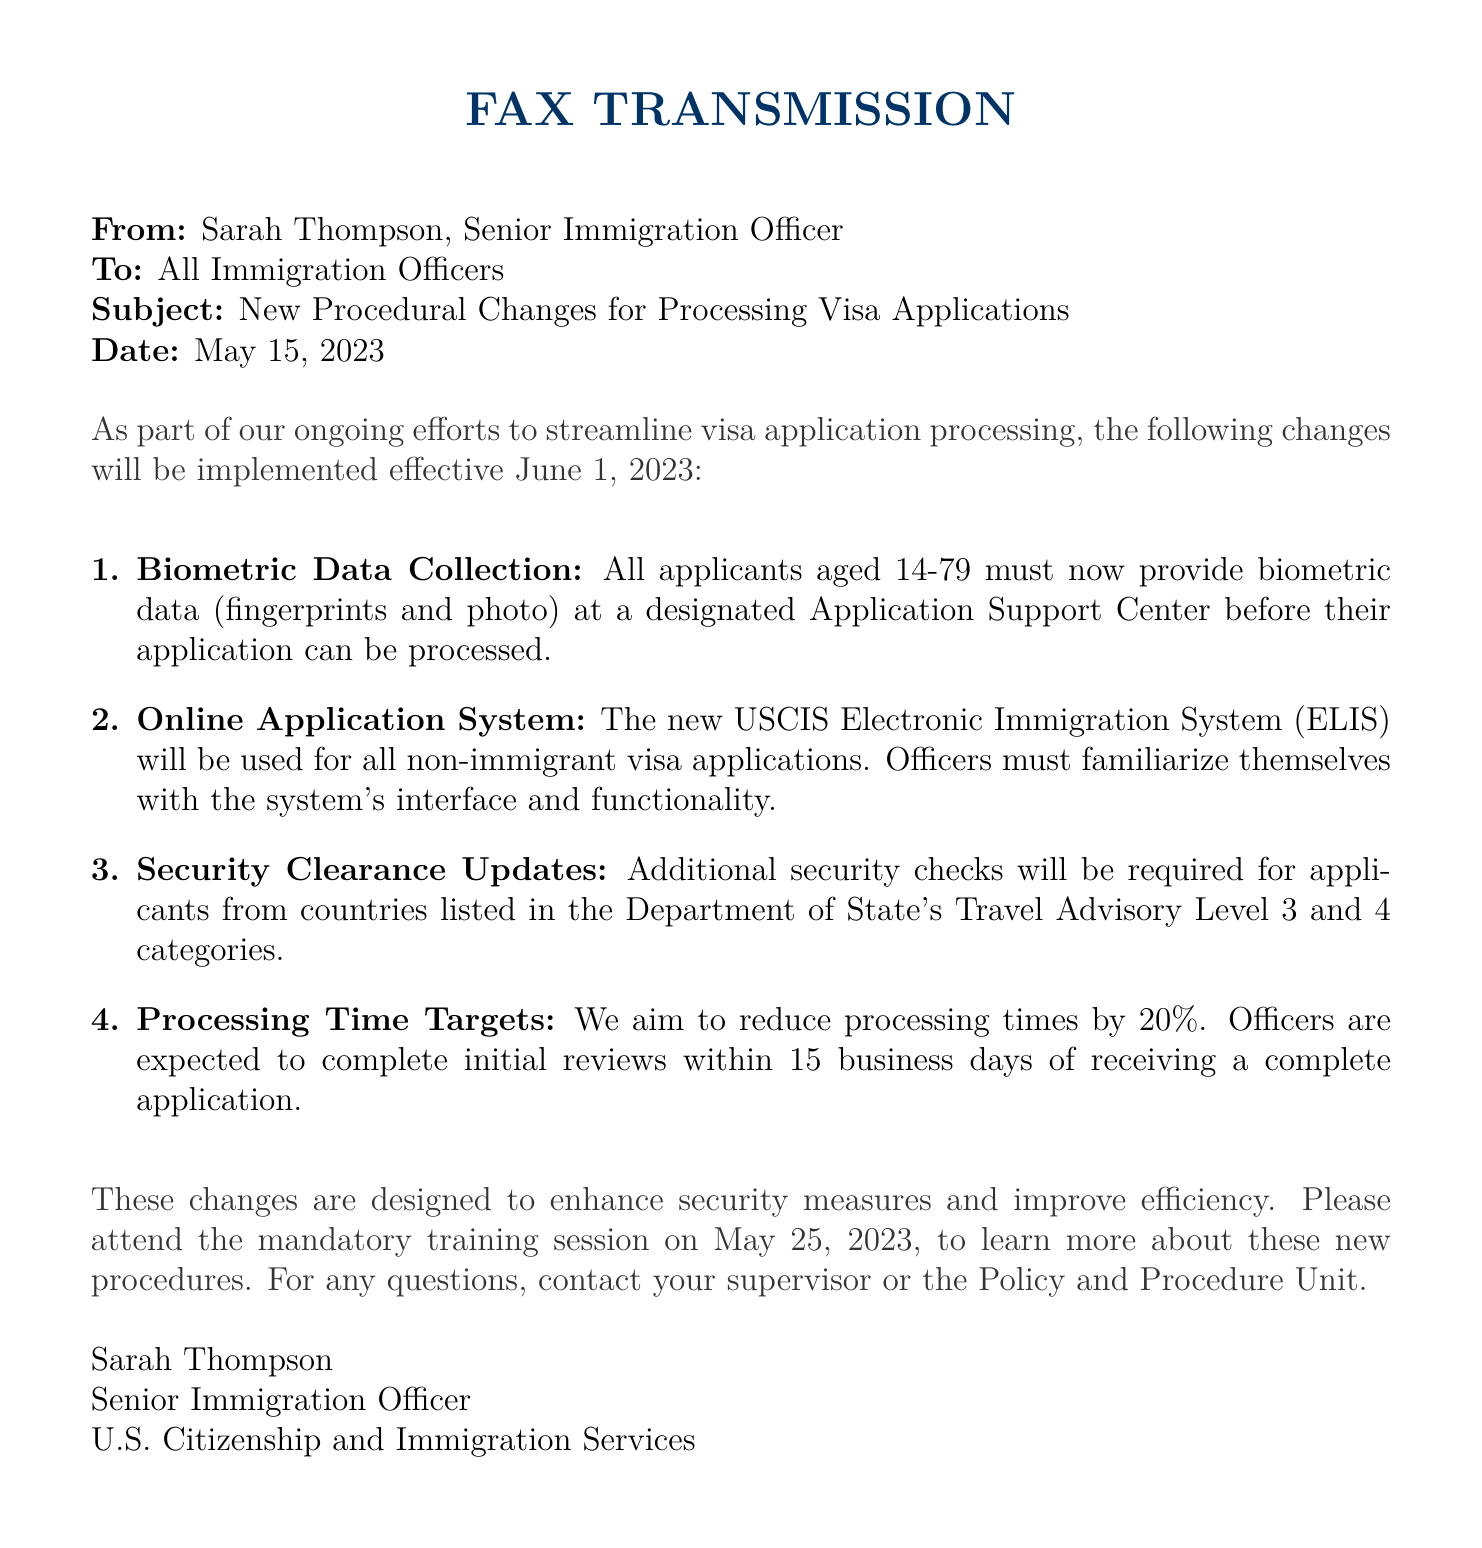what is the subject of the fax? The subject of the fax outlines the main topic addressed in the communication, which is related to procedural changes for visa applications.
Answer: New Procedural Changes for Processing Visa Applications who sent the fax? The sender's name is mentioned at the beginning of the fax, identifying the individual responsible for communicating the new procedures.
Answer: Sarah Thompson when do the new procedures take effect? The effective date for the implementation of the new procedures is explicitly noted in the fax.
Answer: June 1, 2023 what is the age range for biometric data collection? The fax specifies the age requirements for applicants who need to provide biometric data.
Answer: 14-79 how much should processing times be reduced by? The document states a specific percentage reduction aimed for processing times in the visa applications.
Answer: 20% what is the date of the mandatory training session? The fax clearly states when officers must attend a training session regarding the new procedures.
Answer: May 25, 2023 which system will be used for non-immigrant visa applications? The document mentions the new system that immigration officers need to familiarize themselves with for processing visa applications.
Answer: USCIS Electronic Immigration System (ELIS) what must applicants from certain countries undergo? The fax indicates additional requirements that must be fulfilled by applicants from specific travel advisory levels.
Answer: Additional security checks 